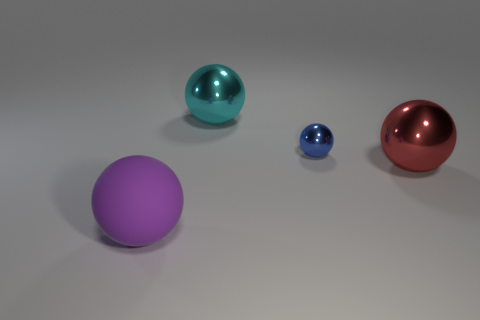The red metal object has what size?
Make the answer very short. Large. How many other things are the same color as the large rubber thing?
Make the answer very short. 0. Is the shape of the large thing behind the large red metallic object the same as  the large red metal thing?
Offer a terse response. Yes. There is a tiny metallic object that is the same shape as the big purple thing; what color is it?
Ensure brevity in your answer.  Blue. Is there anything else that has the same material as the blue sphere?
Make the answer very short. Yes. The blue object that is the same shape as the big red shiny object is what size?
Provide a short and direct response. Small. The ball that is both in front of the tiny shiny sphere and to the left of the red metallic thing is made of what material?
Your answer should be compact. Rubber. Is the color of the big sphere in front of the large red metal object the same as the tiny sphere?
Give a very brief answer. No. There is a tiny metallic ball; does it have the same color as the big metal sphere behind the red metal ball?
Make the answer very short. No. There is a large cyan ball; are there any big rubber spheres behind it?
Make the answer very short. No. 